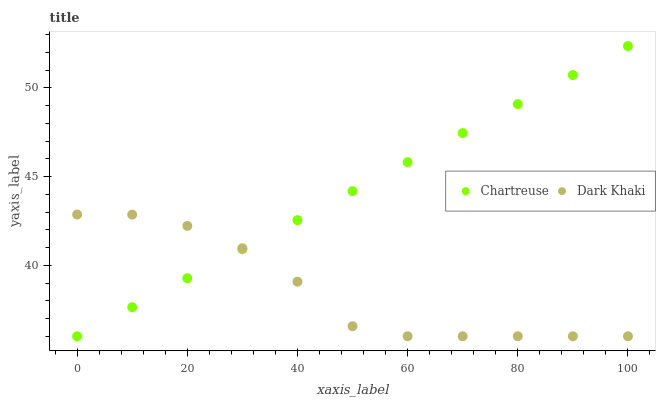Does Dark Khaki have the minimum area under the curve?
Answer yes or no. Yes. Does Chartreuse have the maximum area under the curve?
Answer yes or no. Yes. Does Chartreuse have the minimum area under the curve?
Answer yes or no. No. Is Chartreuse the smoothest?
Answer yes or no. Yes. Is Dark Khaki the roughest?
Answer yes or no. Yes. Is Chartreuse the roughest?
Answer yes or no. No. Does Dark Khaki have the lowest value?
Answer yes or no. Yes. Does Chartreuse have the highest value?
Answer yes or no. Yes. Does Chartreuse intersect Dark Khaki?
Answer yes or no. Yes. Is Chartreuse less than Dark Khaki?
Answer yes or no. No. Is Chartreuse greater than Dark Khaki?
Answer yes or no. No. 